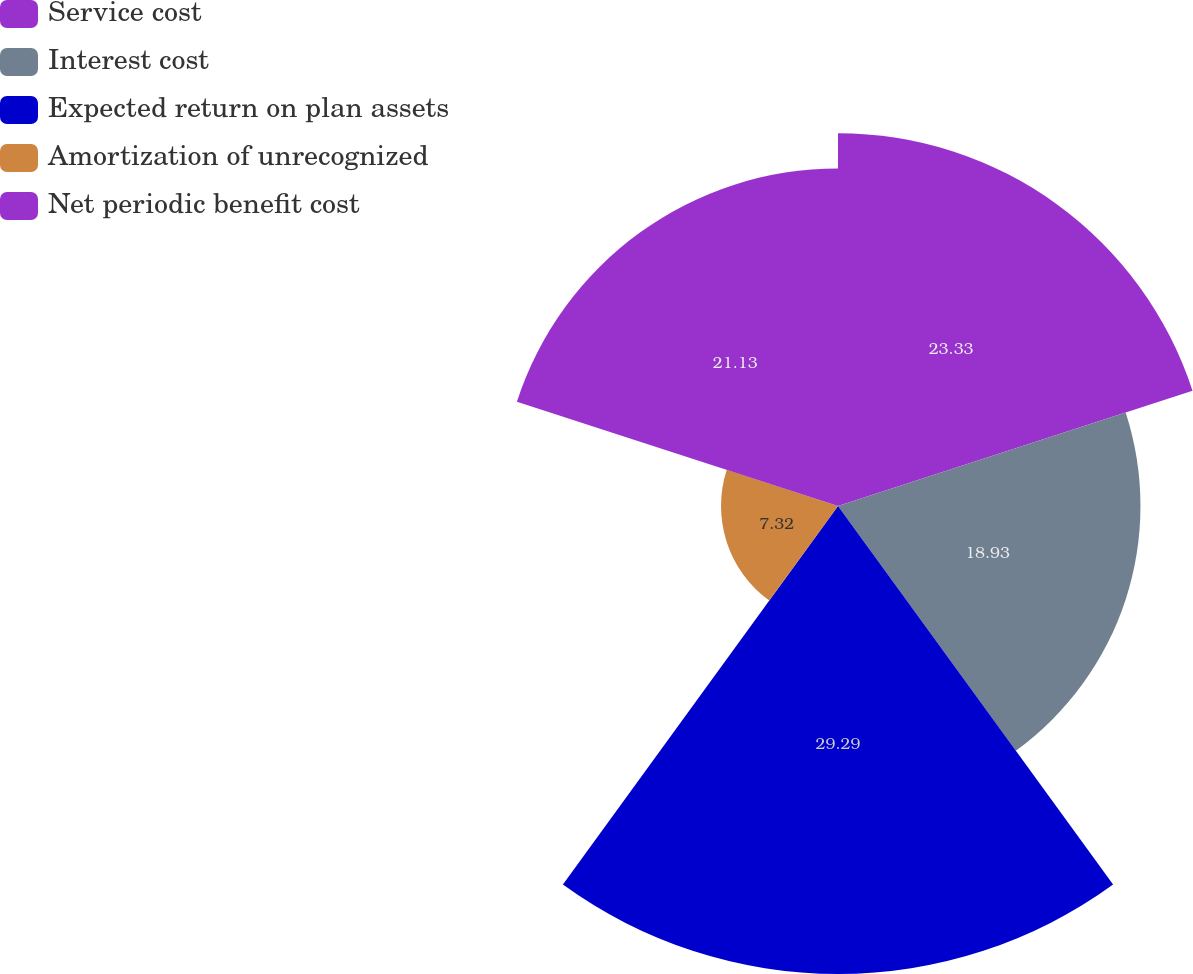Convert chart. <chart><loc_0><loc_0><loc_500><loc_500><pie_chart><fcel>Service cost<fcel>Interest cost<fcel>Expected return on plan assets<fcel>Amortization of unrecognized<fcel>Net periodic benefit cost<nl><fcel>23.33%<fcel>18.93%<fcel>29.29%<fcel>7.32%<fcel>21.13%<nl></chart> 